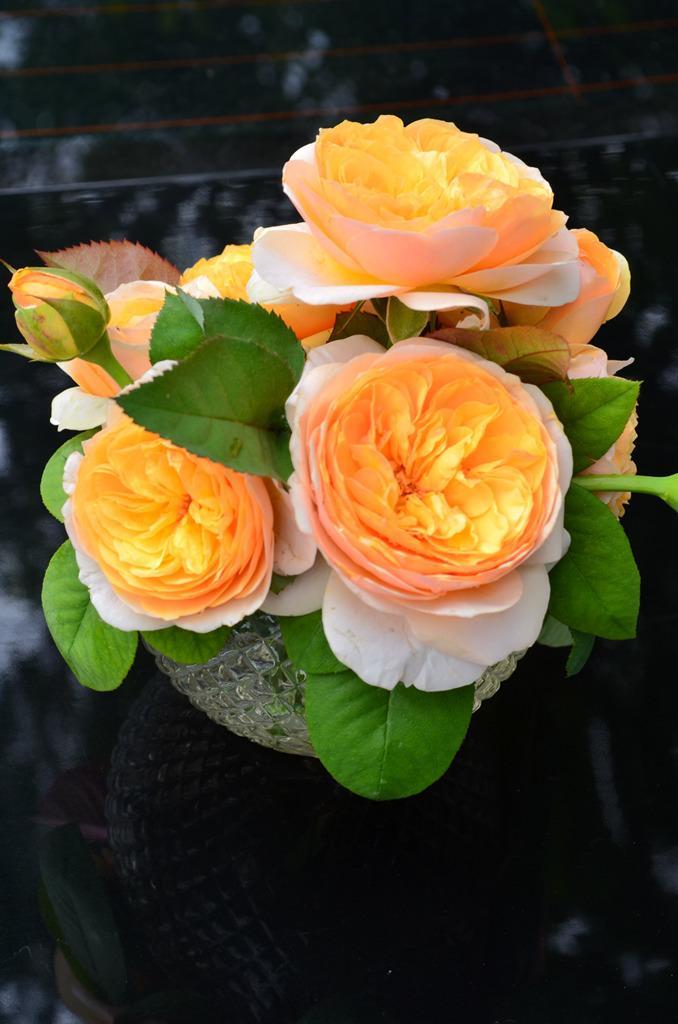Could you give a brief overview of what you see in this image? In this picture we can see a flower vase. 